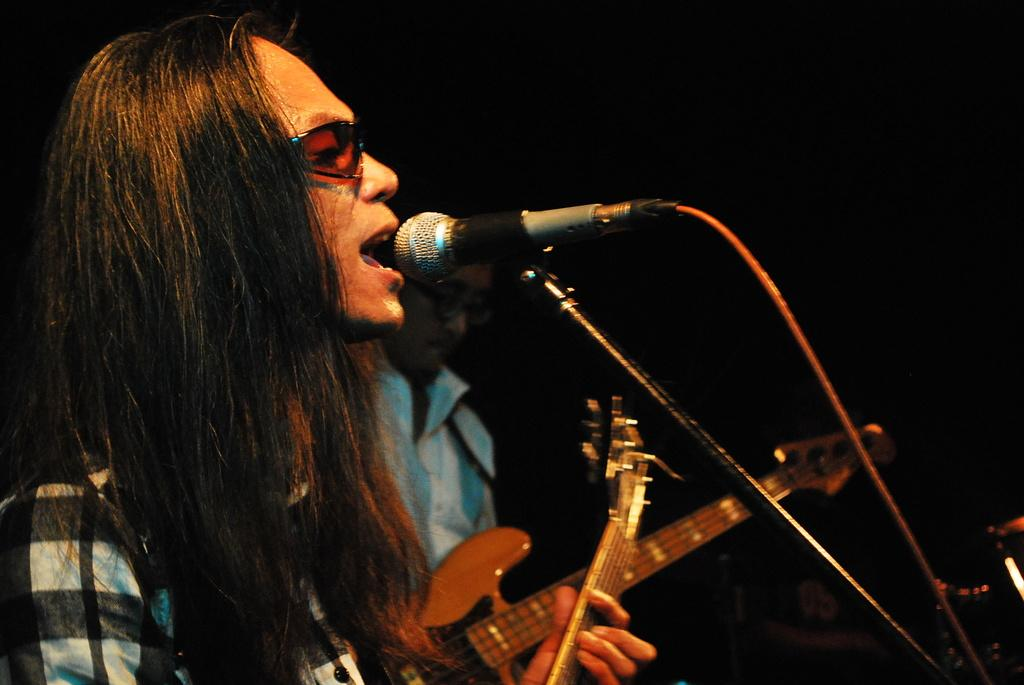How many people are in the image? There are two people in the image. What are the two people doing in the image? The two people are standing in front of a microphone and singing. What instruments are the two people playing in the image? The two people are playing guitar in the image. What type of cart is being used to transport the pencil in the image? There is no cart or pencil present in the image. 